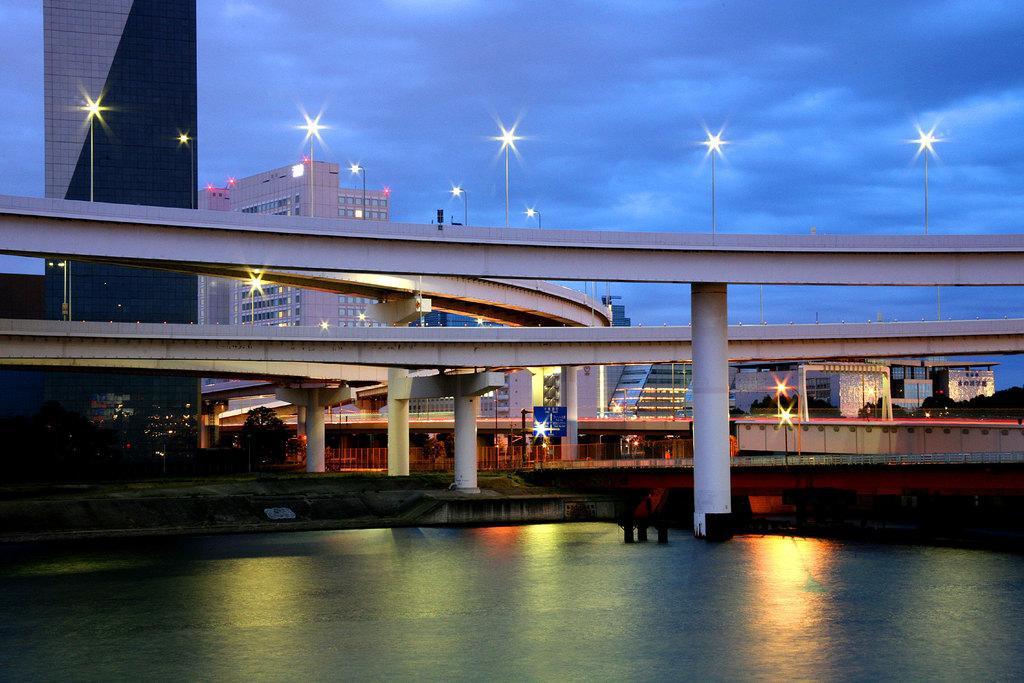Describe this image in one or two sentences. In the foreground of the picture there is a water body. In the center of the picture there are bridges, lights, trees and other objects. In the background there are building, trees and street lights. Sky is cloudy. 